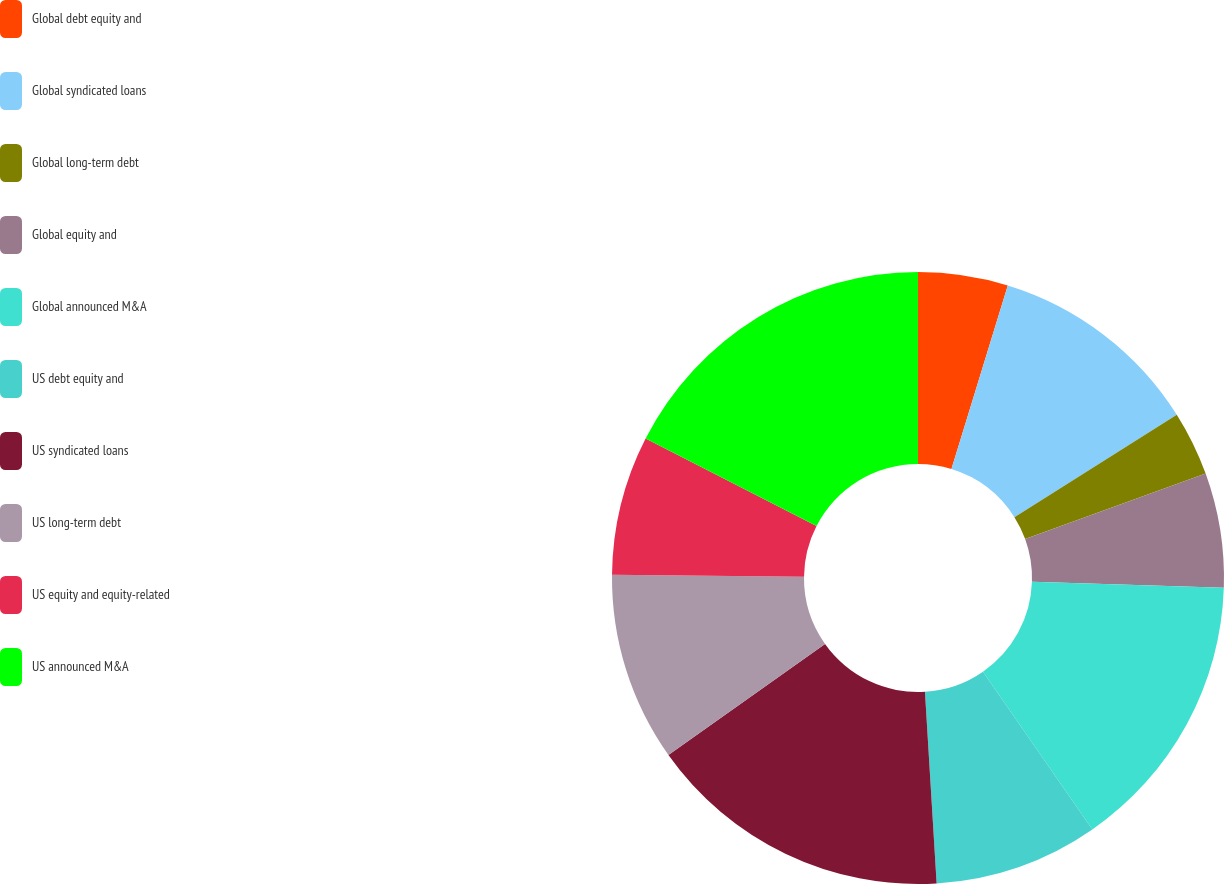<chart> <loc_0><loc_0><loc_500><loc_500><pie_chart><fcel>Global debt equity and<fcel>Global syndicated loans<fcel>Global long-term debt<fcel>Global equity and<fcel>Global announced M&A<fcel>US debt equity and<fcel>US syndicated loans<fcel>US long-term debt<fcel>US equity and equity-related<fcel>US announced M&A<nl><fcel>4.74%<fcel>11.3%<fcel>3.42%<fcel>6.05%<fcel>14.84%<fcel>8.68%<fcel>16.15%<fcel>9.99%<fcel>7.36%<fcel>17.47%<nl></chart> 